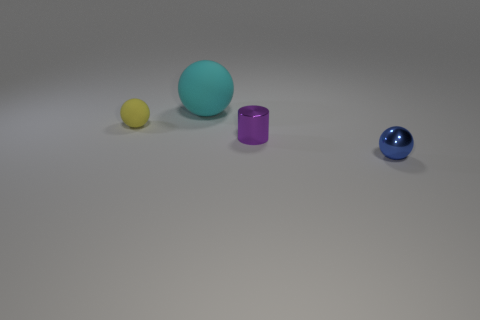Subtract all tiny rubber balls. How many balls are left? 2 Subtract 1 cylinders. How many cylinders are left? 0 Add 1 tiny yellow matte objects. How many objects exist? 5 Subtract all blue balls. How many balls are left? 2 Subtract all cylinders. How many objects are left? 3 Add 1 cyan rubber things. How many cyan rubber things are left? 2 Add 2 large gray matte cylinders. How many large gray matte cylinders exist? 2 Subtract 0 yellow cylinders. How many objects are left? 4 Subtract all brown balls. Subtract all purple cylinders. How many balls are left? 3 Subtract all yellow spheres. How many cyan cylinders are left? 0 